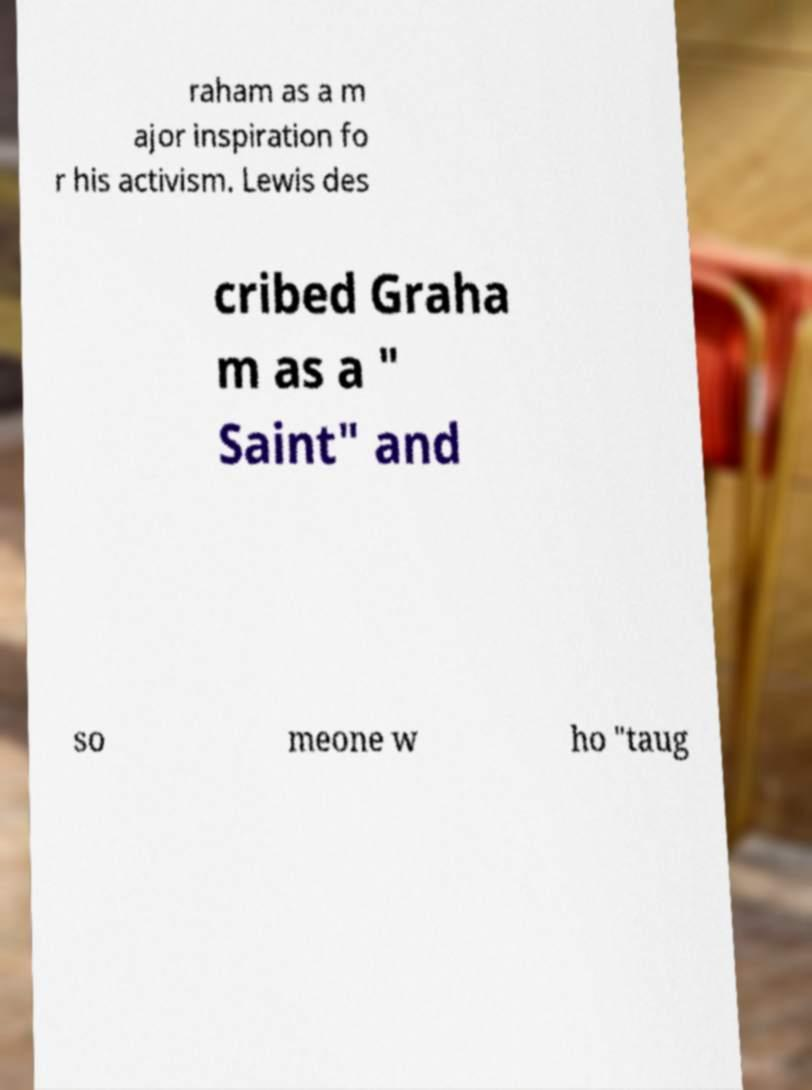For documentation purposes, I need the text within this image transcribed. Could you provide that? raham as a m ajor inspiration fo r his activism. Lewis des cribed Graha m as a " Saint" and so meone w ho "taug 